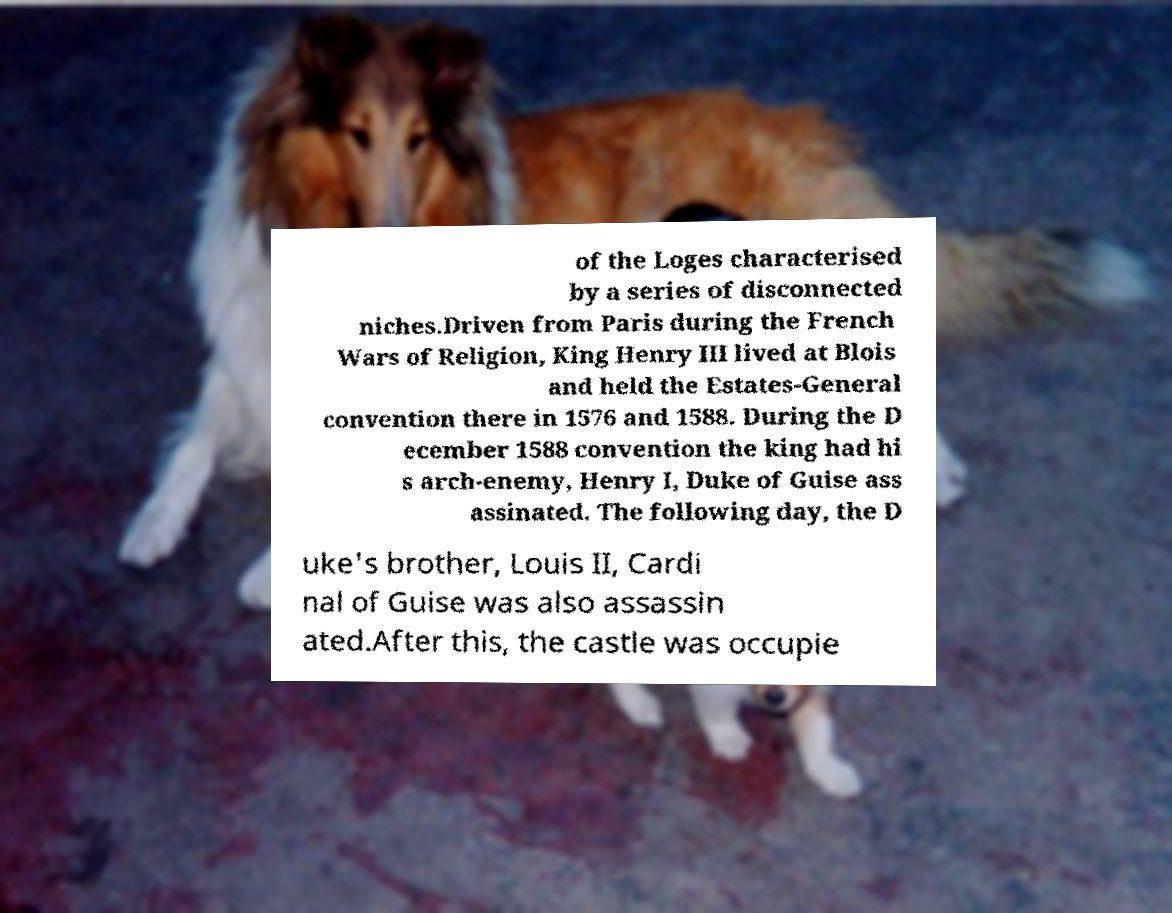I need the written content from this picture converted into text. Can you do that? of the Loges characterised by a series of disconnected niches.Driven from Paris during the French Wars of Religion, King Henry III lived at Blois and held the Estates-General convention there in 1576 and 1588. During the D ecember 1588 convention the king had hi s arch-enemy, Henry I, Duke of Guise ass assinated. The following day, the D uke's brother, Louis II, Cardi nal of Guise was also assassin ated.After this, the castle was occupie 